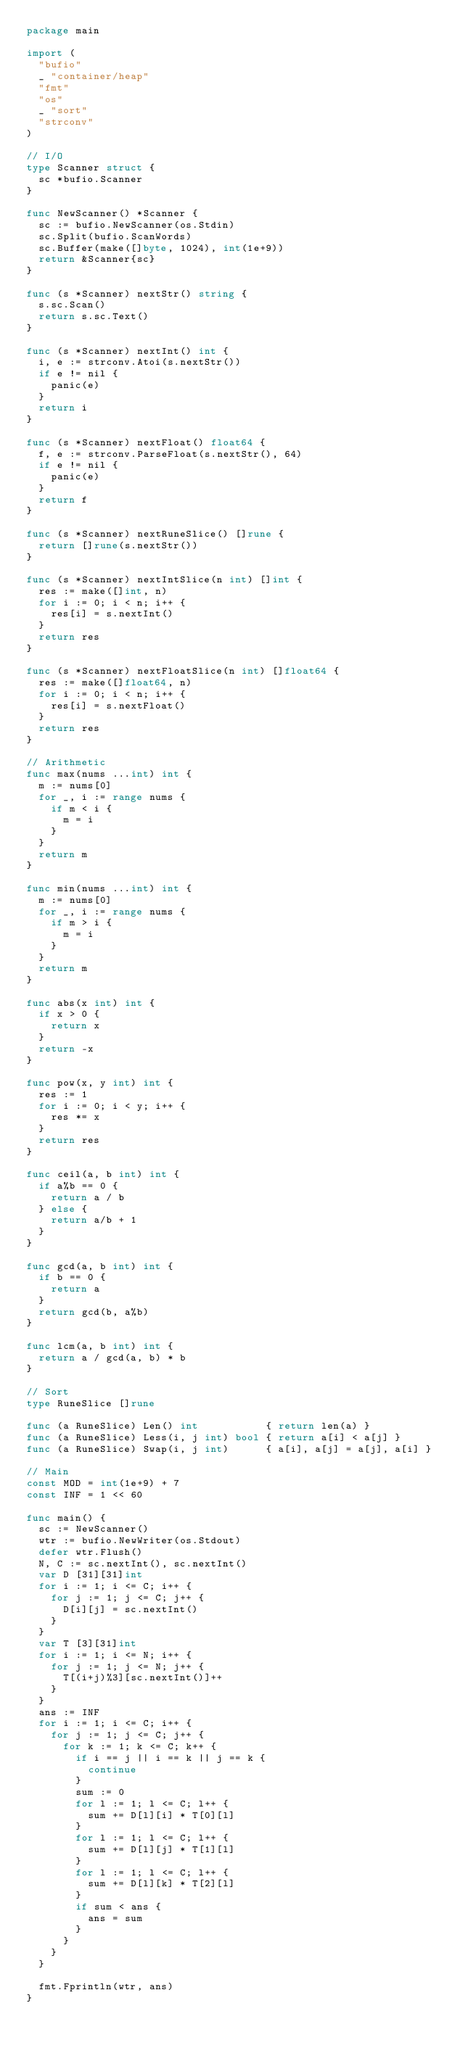<code> <loc_0><loc_0><loc_500><loc_500><_Go_>package main

import (
	"bufio"
	_ "container/heap"
	"fmt"
	"os"
	_ "sort"
	"strconv"
)

// I/O
type Scanner struct {
	sc *bufio.Scanner
}

func NewScanner() *Scanner {
	sc := bufio.NewScanner(os.Stdin)
	sc.Split(bufio.ScanWords)
	sc.Buffer(make([]byte, 1024), int(1e+9))
	return &Scanner{sc}
}

func (s *Scanner) nextStr() string {
	s.sc.Scan()
	return s.sc.Text()
}

func (s *Scanner) nextInt() int {
	i, e := strconv.Atoi(s.nextStr())
	if e != nil {
		panic(e)
	}
	return i
}

func (s *Scanner) nextFloat() float64 {
	f, e := strconv.ParseFloat(s.nextStr(), 64)
	if e != nil {
		panic(e)
	}
	return f
}

func (s *Scanner) nextRuneSlice() []rune {
	return []rune(s.nextStr())
}

func (s *Scanner) nextIntSlice(n int) []int {
	res := make([]int, n)
	for i := 0; i < n; i++ {
		res[i] = s.nextInt()
	}
	return res
}

func (s *Scanner) nextFloatSlice(n int) []float64 {
	res := make([]float64, n)
	for i := 0; i < n; i++ {
		res[i] = s.nextFloat()
	}
	return res
}

// Arithmetic
func max(nums ...int) int {
	m := nums[0]
	for _, i := range nums {
		if m < i {
			m = i
		}
	}
	return m
}

func min(nums ...int) int {
	m := nums[0]
	for _, i := range nums {
		if m > i {
			m = i
		}
	}
	return m
}

func abs(x int) int {
	if x > 0 {
		return x
	}
	return -x
}

func pow(x, y int) int {
	res := 1
	for i := 0; i < y; i++ {
		res *= x
	}
	return res
}

func ceil(a, b int) int {
	if a%b == 0 {
		return a / b
	} else {
		return a/b + 1
	}
}

func gcd(a, b int) int {
	if b == 0 {
		return a
	}
	return gcd(b, a%b)
}

func lcm(a, b int) int {
	return a / gcd(a, b) * b
}

// Sort
type RuneSlice []rune

func (a RuneSlice) Len() int           { return len(a) }
func (a RuneSlice) Less(i, j int) bool { return a[i] < a[j] }
func (a RuneSlice) Swap(i, j int)      { a[i], a[j] = a[j], a[i] }

// Main
const MOD = int(1e+9) + 7
const INF = 1 << 60

func main() {
	sc := NewScanner()
	wtr := bufio.NewWriter(os.Stdout)
	defer wtr.Flush()
	N, C := sc.nextInt(), sc.nextInt()
	var D [31][31]int
	for i := 1; i <= C; i++ {
		for j := 1; j <= C; j++ {
			D[i][j] = sc.nextInt()
		}
	}
	var T [3][31]int
	for i := 1; i <= N; i++ {
		for j := 1; j <= N; j++ {
			T[(i+j)%3][sc.nextInt()]++
		}
	}
	ans := INF
	for i := 1; i <= C; i++ {
		for j := 1; j <= C; j++ {
			for k := 1; k <= C; k++ {
				if i == j || i == k || j == k {
					continue
				}
				sum := 0
				for l := 1; l <= C; l++ {
					sum += D[l][i] * T[0][l]
				}
				for l := 1; l <= C; l++ {
					sum += D[l][j] * T[1][l]
				}
				for l := 1; l <= C; l++ {
					sum += D[l][k] * T[2][l]
				}
				if sum < ans {
					ans = sum
				}
			}
		}
	}

	fmt.Fprintln(wtr, ans)
}
</code> 